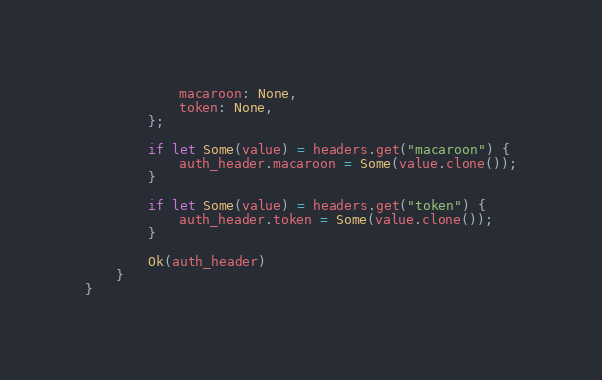<code> <loc_0><loc_0><loc_500><loc_500><_Rust_>            macaroon: None,
            token: None,
        };

        if let Some(value) = headers.get("macaroon") {
            auth_header.macaroon = Some(value.clone());
        }

        if let Some(value) = headers.get("token") {
            auth_header.token = Some(value.clone());
        }

        Ok(auth_header)
    }
}
</code> 